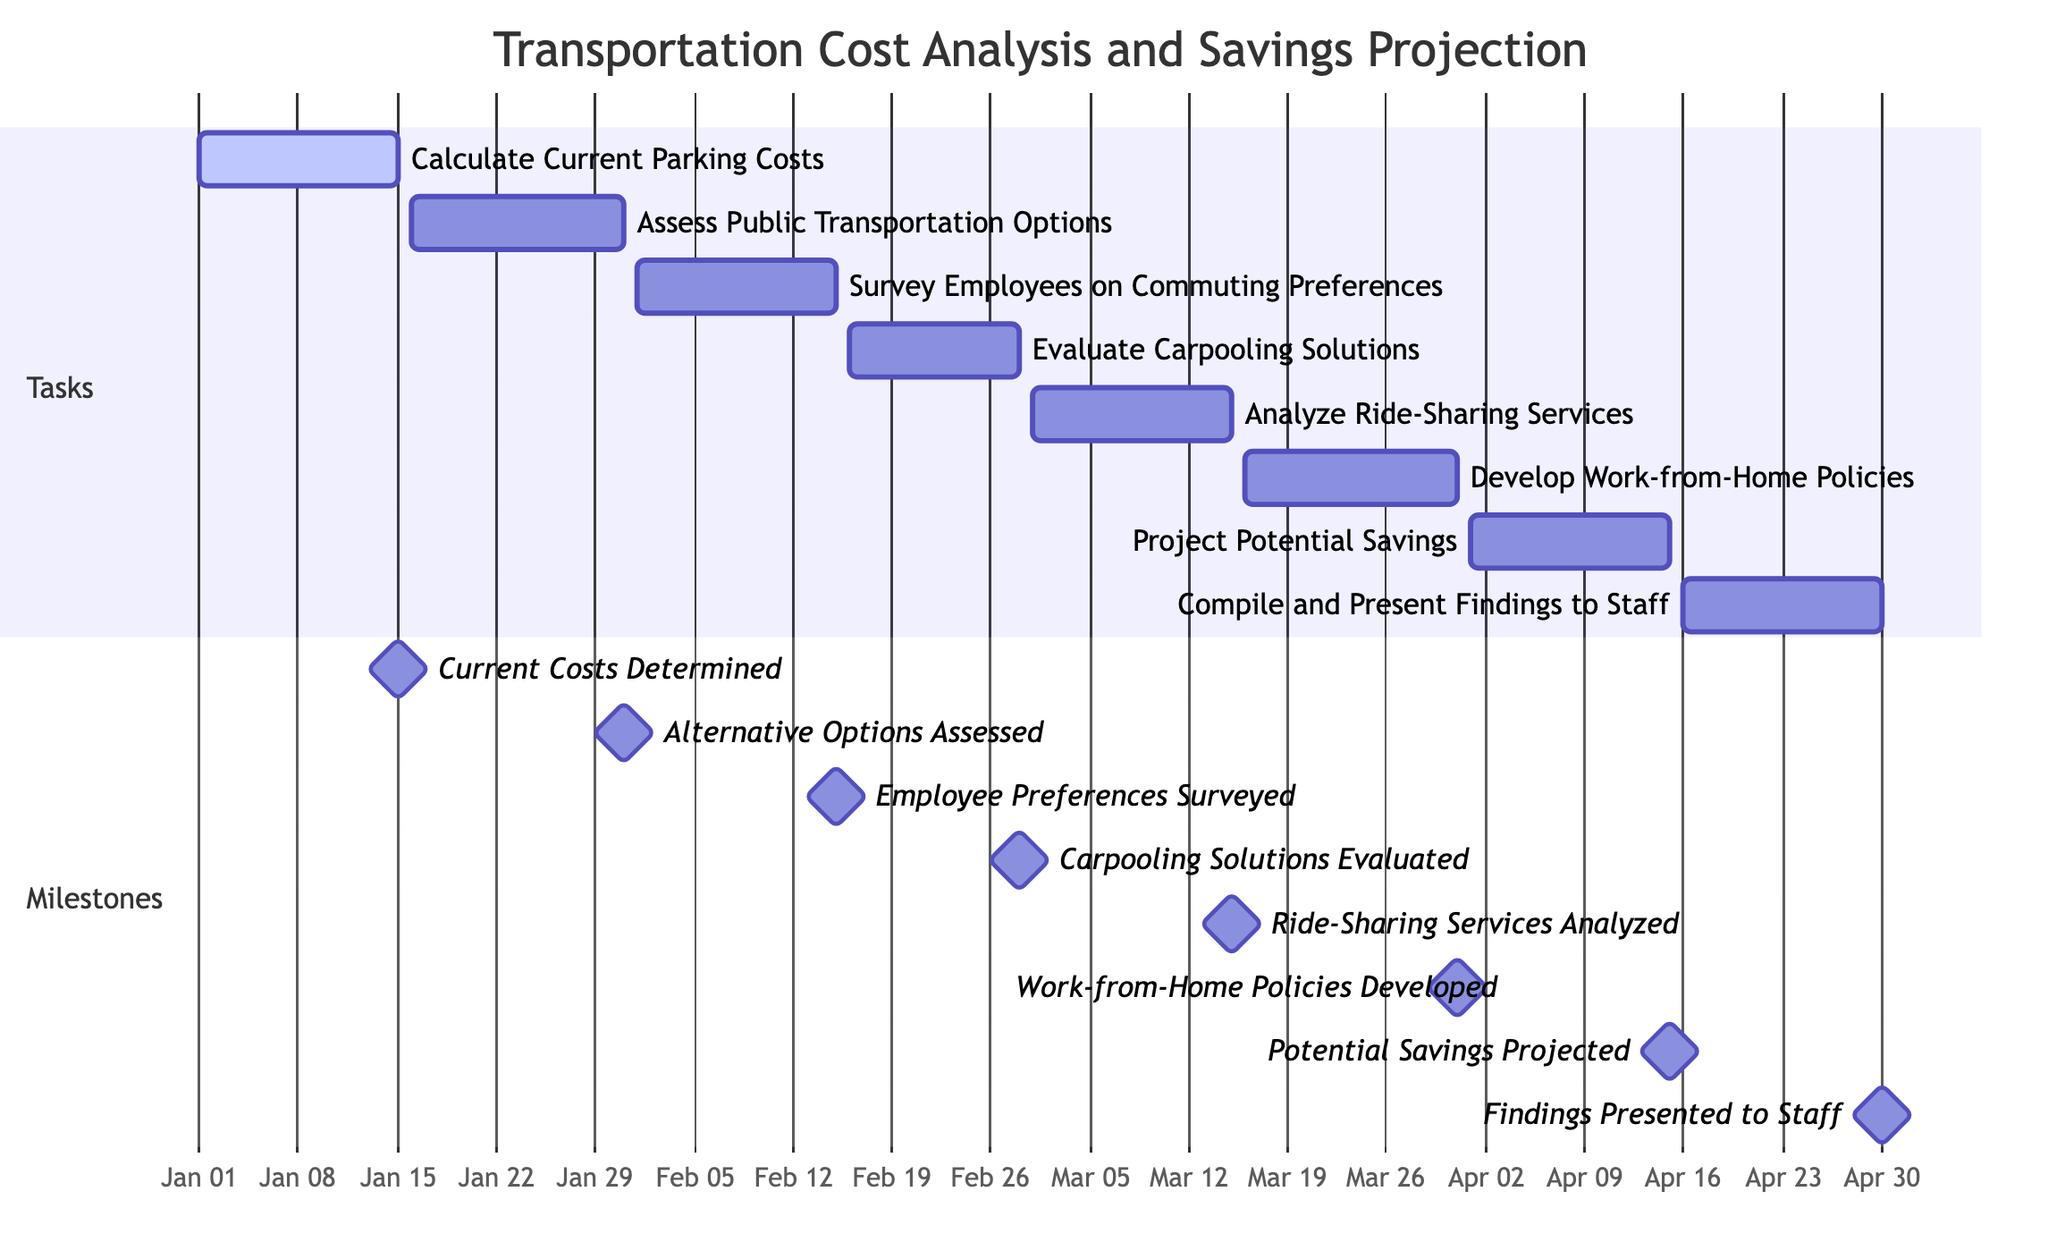What is the duration of the task "Survey Employees on Commuting Preferences"? The task "Survey Employees on Commuting Preferences" starts on February 1, 2023, and ends on February 15, 2023. The duration is calculated as the difference between the end date and start date, resulting in 15 days.
Answer: 15 days What task comes after "Evaluate Carpooling Solutions"? "Evaluate Carpooling Solutions" ends on February 28, 2023, and the next task that starts directly after it is "Analyze Ride-Sharing Services," which begins on March 1, 2023.
Answer: Analyze Ride-Sharing Services On what date is the milestone "Work-from-Home Policies Developed"? The milestone "Work-from-Home Policies Developed" is marked on March 31, 2023, as per the milestones section of the diagram.
Answer: March 31, 2023 How many tasks must be completed before projecting potential savings? To project potential savings, the task "Develop Work-from-Home Policies" must be completed, which is dependent on completing "Analyze Ride-Sharing Services," "Evaluate Carpooling Solutions," and "Survey Employees on Commuting Preferences." Altogether, three tasks must be completed.
Answer: 3 tasks What is the start date of the task "Compile and Present Findings to Staff"? The task "Compile and Present Findings to Staff" starts on April 16, 2023, as shown in the tasks section of the diagram.
Answer: April 16, 2023 What is the last milestone in the project timeline? The last milestone in the project timeline is "Findings Presented to Staff," occurring on April 30, 2023, representing the final point of the project tasks and milestones.
Answer: Findings Presented to Staff What is the relationship between "Assess Public Transportation Options" and "Survey Employees on Commuting Preferences"? "Assess Public Transportation Options" must be completed before "Survey Employees on Commuting Preferences" can begin; thus, it shows a dependency relationship where the second task relies on the completion of the first.
Answer: Dependency relationship When does the task "Project Potential Savings" end? The task "Project Potential Savings" ends on April 15, 2023, according to the timeline specified in the tasks section.
Answer: April 15, 2023 